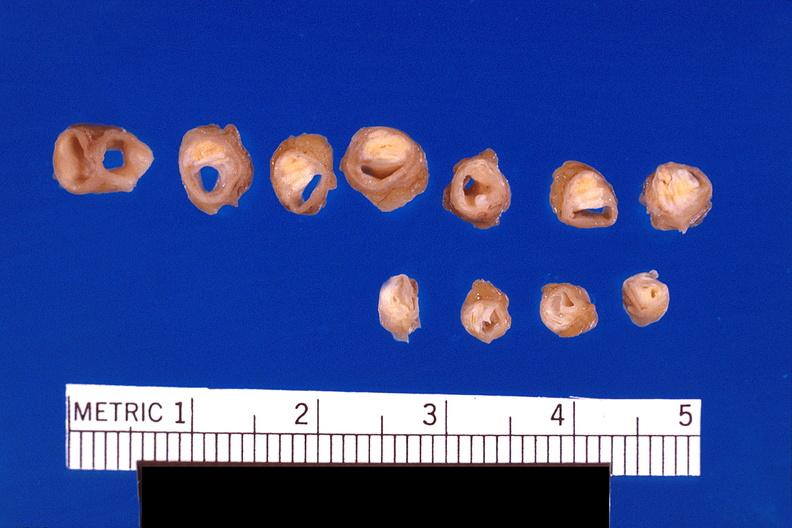what left anterior descending coronary artery?
Answer the question using a single word or phrase. Atherosclerosis 